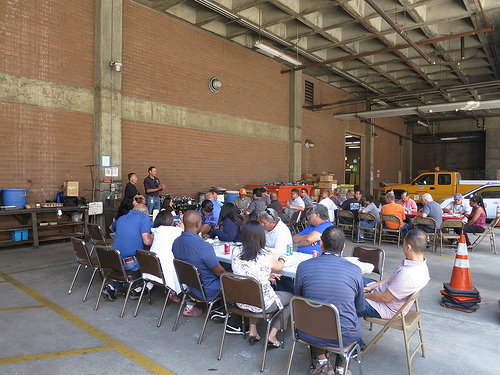<image>
Can you confirm if the guy is behind the guy? No. The guy is not behind the guy. From this viewpoint, the guy appears to be positioned elsewhere in the scene. 